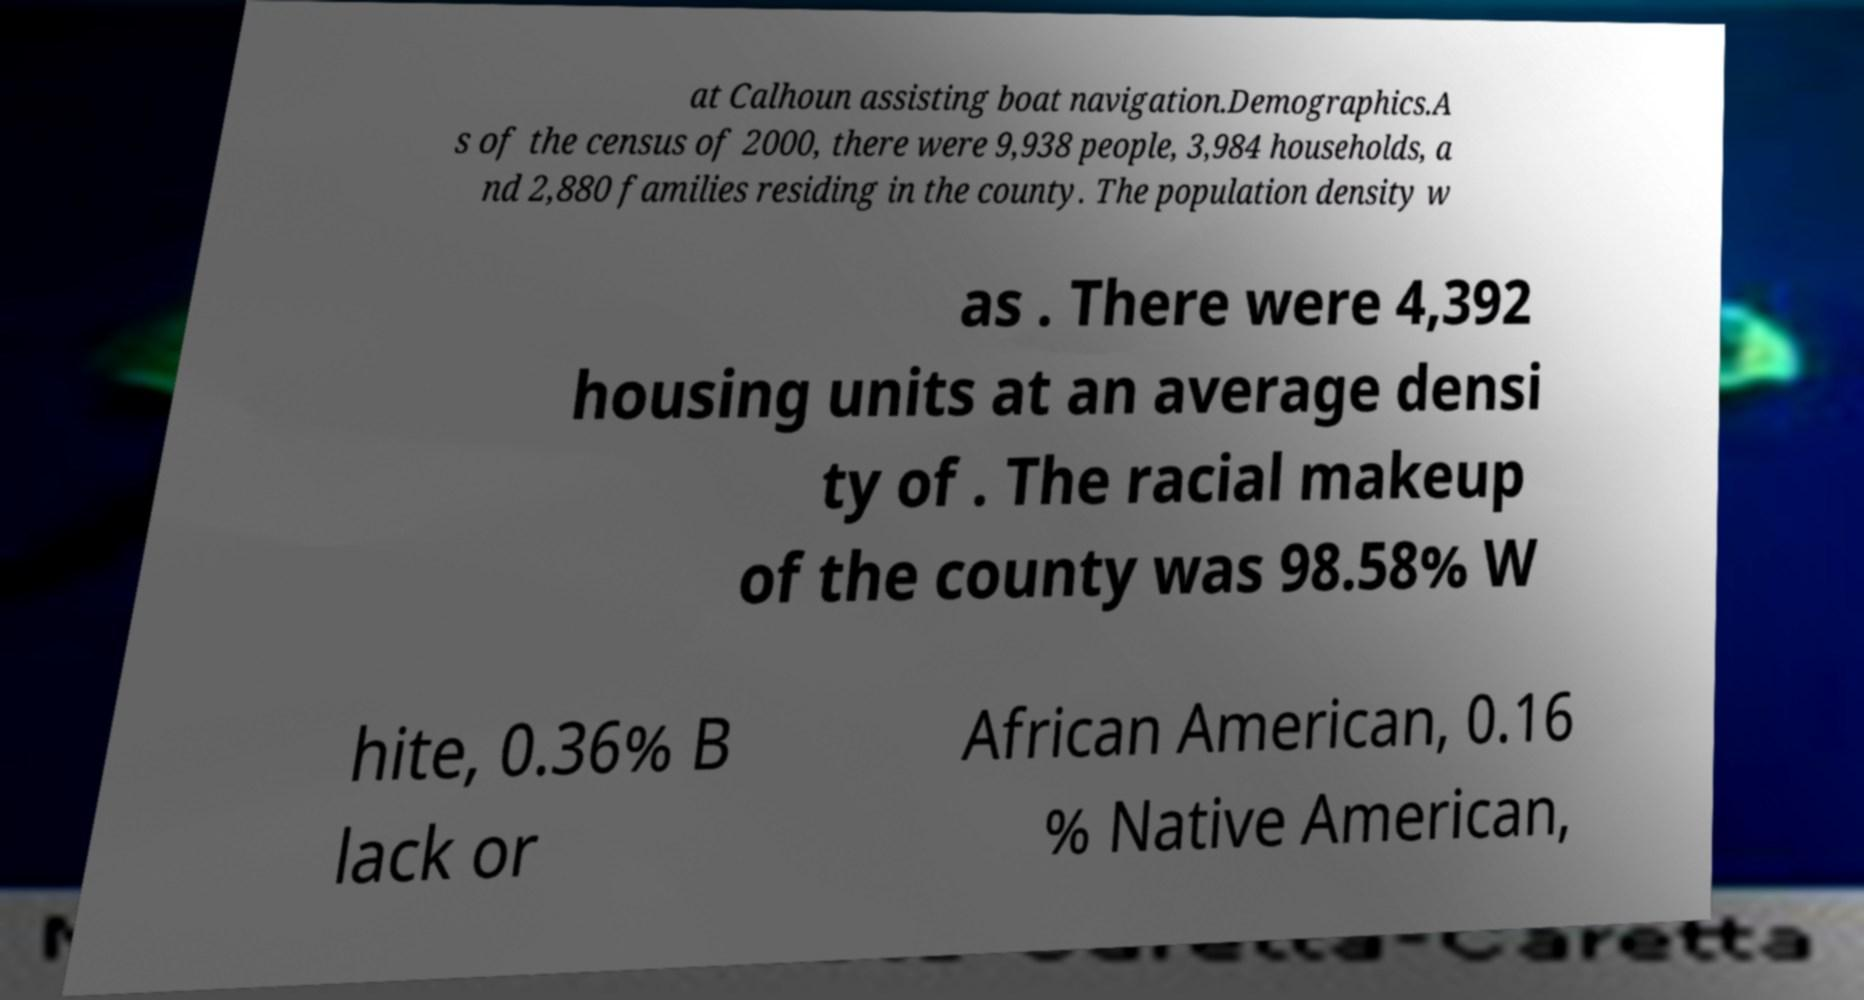Can you accurately transcribe the text from the provided image for me? at Calhoun assisting boat navigation.Demographics.A s of the census of 2000, there were 9,938 people, 3,984 households, a nd 2,880 families residing in the county. The population density w as . There were 4,392 housing units at an average densi ty of . The racial makeup of the county was 98.58% W hite, 0.36% B lack or African American, 0.16 % Native American, 